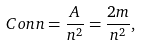Convert formula to latex. <formula><loc_0><loc_0><loc_500><loc_500>C o n n = \frac { A } { n ^ { 2 } } = \frac { 2 m } { n ^ { 2 } } ,</formula> 